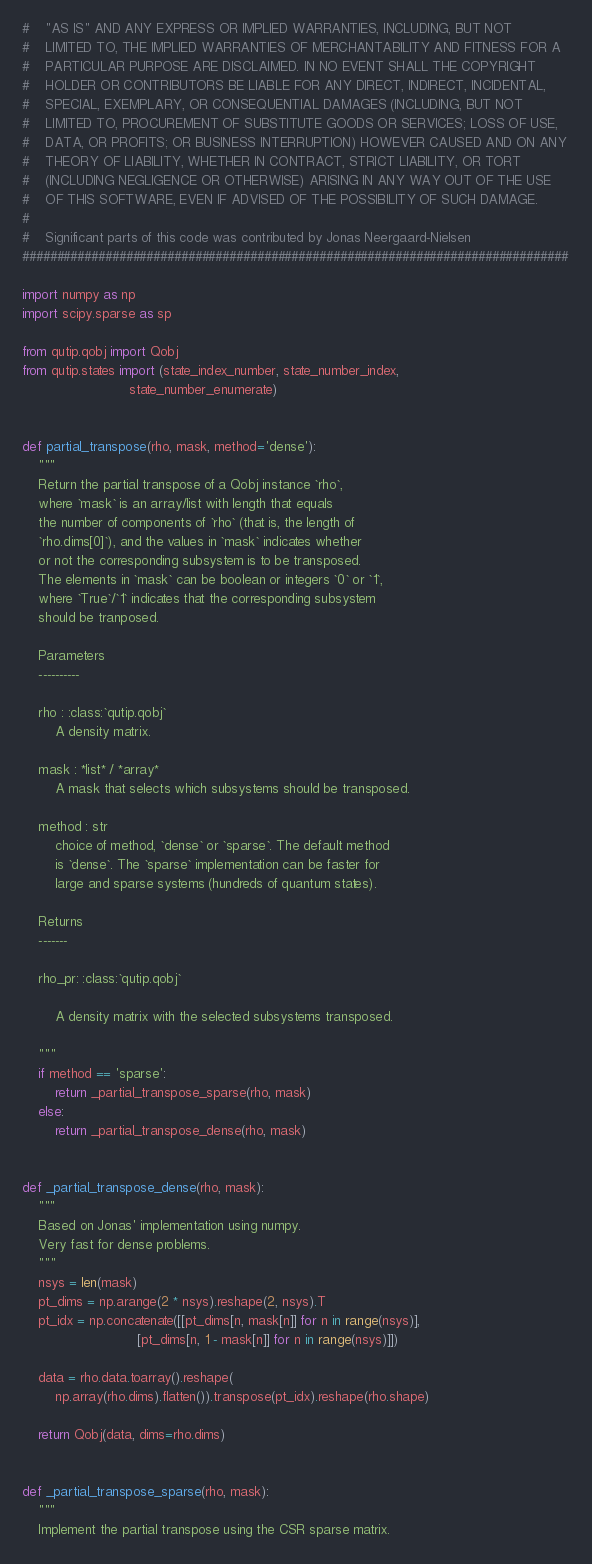Convert code to text. <code><loc_0><loc_0><loc_500><loc_500><_Python_>#    "AS IS" AND ANY EXPRESS OR IMPLIED WARRANTIES, INCLUDING, BUT NOT
#    LIMITED TO, THE IMPLIED WARRANTIES OF MERCHANTABILITY AND FITNESS FOR A 
#    PARTICULAR PURPOSE ARE DISCLAIMED. IN NO EVENT SHALL THE COPYRIGHT 
#    HOLDER OR CONTRIBUTORS BE LIABLE FOR ANY DIRECT, INDIRECT, INCIDENTAL, 
#    SPECIAL, EXEMPLARY, OR CONSEQUENTIAL DAMAGES (INCLUDING, BUT NOT 
#    LIMITED TO, PROCUREMENT OF SUBSTITUTE GOODS OR SERVICES; LOSS OF USE, 
#    DATA, OR PROFITS; OR BUSINESS INTERRUPTION) HOWEVER CAUSED AND ON ANY 
#    THEORY OF LIABILITY, WHETHER IN CONTRACT, STRICT LIABILITY, OR TORT 
#    (INCLUDING NEGLIGENCE OR OTHERWISE) ARISING IN ANY WAY OUT OF THE USE 
#    OF THIS SOFTWARE, EVEN IF ADVISED OF THE POSSIBILITY OF SUCH DAMAGE.
#
#    Significant parts of this code was contributed by Jonas Neergaard-Nielsen
###############################################################################

import numpy as np
import scipy.sparse as sp

from qutip.qobj import Qobj
from qutip.states import (state_index_number, state_number_index,
                          state_number_enumerate)


def partial_transpose(rho, mask, method='dense'):
    """
    Return the partial transpose of a Qobj instance `rho`,
    where `mask` is an array/list with length that equals
    the number of components of `rho` (that is, the length of
    `rho.dims[0]`), and the values in `mask` indicates whether
    or not the corresponding subsystem is to be transposed.
    The elements in `mask` can be boolean or integers `0` or `1`,
    where `True`/`1` indicates that the corresponding subsystem
    should be tranposed.

    Parameters
    ----------

    rho : :class:`qutip.qobj`
        A density matrix.

    mask : *list* / *array*
        A mask that selects which subsystems should be transposed.

    method : str
        choice of method, `dense` or `sparse`. The default method
        is `dense`. The `sparse` implementation can be faster for
        large and sparse systems (hundreds of quantum states).

    Returns
    -------

    rho_pr: :class:`qutip.qobj`

        A density matrix with the selected subsystems transposed.

    """
    if method == 'sparse':
        return _partial_transpose_sparse(rho, mask)
    else:
        return _partial_transpose_dense(rho, mask)


def _partial_transpose_dense(rho, mask):
    """
    Based on Jonas' implementation using numpy.
    Very fast for dense problems.
    """
    nsys = len(mask)
    pt_dims = np.arange(2 * nsys).reshape(2, nsys).T
    pt_idx = np.concatenate([[pt_dims[n, mask[n]] for n in range(nsys)],
                            [pt_dims[n, 1 - mask[n]] for n in range(nsys)]])

    data = rho.data.toarray().reshape(
        np.array(rho.dims).flatten()).transpose(pt_idx).reshape(rho.shape)

    return Qobj(data, dims=rho.dims)


def _partial_transpose_sparse(rho, mask):
    """
    Implement the partial transpose using the CSR sparse matrix.</code> 